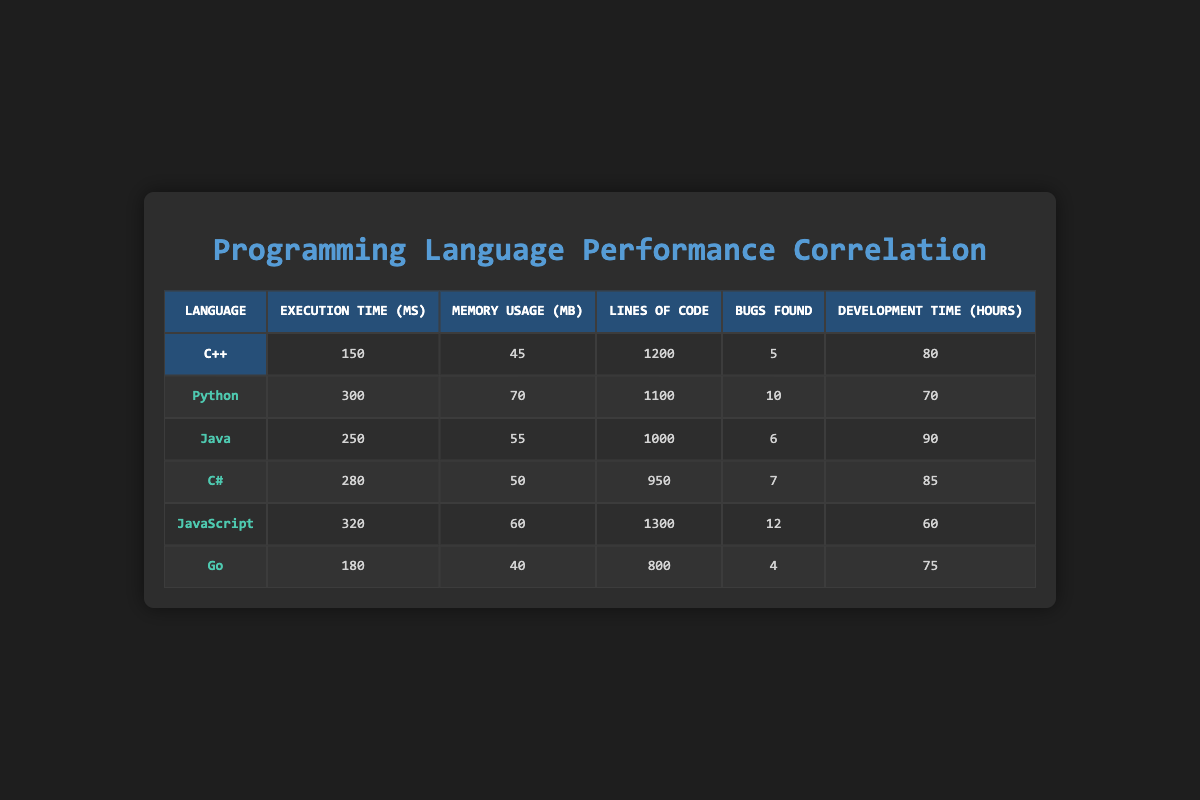What is the execution time of Python? The execution time for Python is listed in the table under the "Execution Time (ms)" column. It shows 300 milliseconds for Python.
Answer: 300 ms Which language has the lowest memory usage? From the "Memory Usage (MB)" column, we can see that Go has the lowest memory usage at 40 MB.
Answer: Go What is the total number of bugs found across all programming languages? To find the total number of bugs, we sum the values in the "Bugs Found" column: 5 + 10 + 6 + 7 + 12 + 4 = 44.
Answer: 44 Is the development time for Java greater than that for C#? By comparing the "Development Time (hours)" for Java (90 hours) and C# (85 hours), we see that Java's development time is indeed greater.
Answer: Yes What is the average execution time of the programming languages listed? We calculate the average by summing the execution times: 150 + 300 + 250 + 280 + 320 + 180 = 1480 ms. Then, we divide by the number of languages, which is 6: 1480 / 6 ≈ 246.67 ms.
Answer: 246.67 ms What language has the highest number of bugs found? The "Bugs Found" column reveals that JavaScript has the highest number of bugs at 12.
Answer: JavaScript What is the difference in execution time between C++ and JavaScript? The execution time for C++ is 150 ms and for JavaScript, it is 320 ms. The difference is: 320 - 150 = 170 ms.
Answer: 170 ms Which language has the most lines of code? Looking at the "Lines of Code" column, JavaScript has the most lines at 1300.
Answer: JavaScript Is Go's execution time lower than that for C#? Go's execution time is 180 ms, while C#'s execution time is 280 ms. Since 180 is less than 280, Go has a lower execution time.
Answer: Yes 